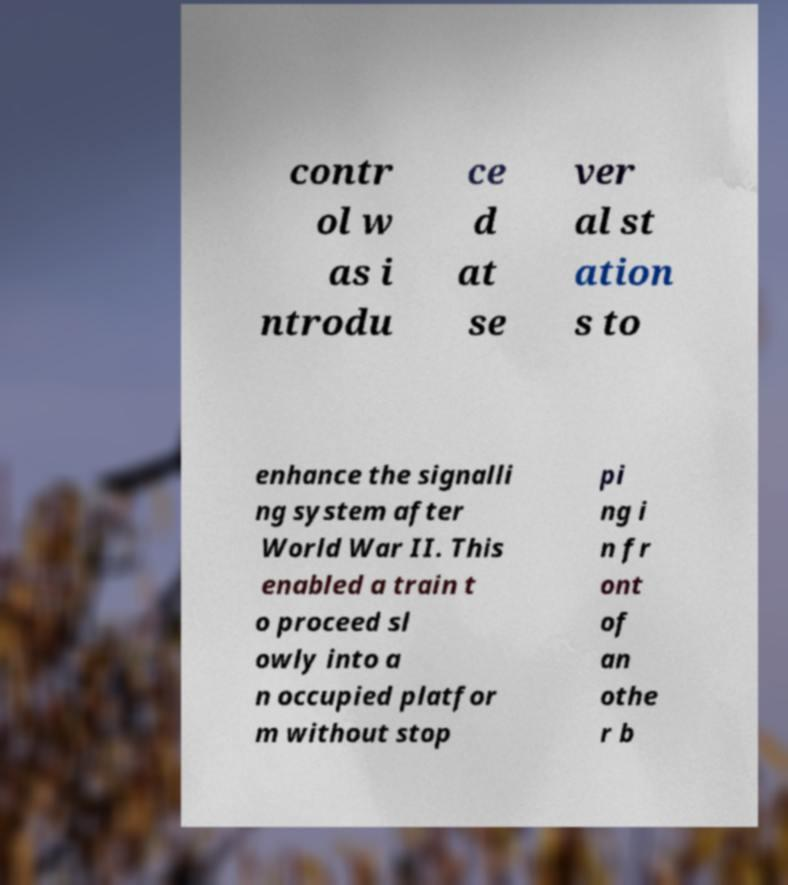What messages or text are displayed in this image? I need them in a readable, typed format. contr ol w as i ntrodu ce d at se ver al st ation s to enhance the signalli ng system after World War II. This enabled a train t o proceed sl owly into a n occupied platfor m without stop pi ng i n fr ont of an othe r b 